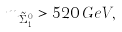<formula> <loc_0><loc_0><loc_500><loc_500>m _ { \tilde { \Sigma } _ { 1 } ^ { 0 } } > 5 2 0 \, G e V ,</formula> 